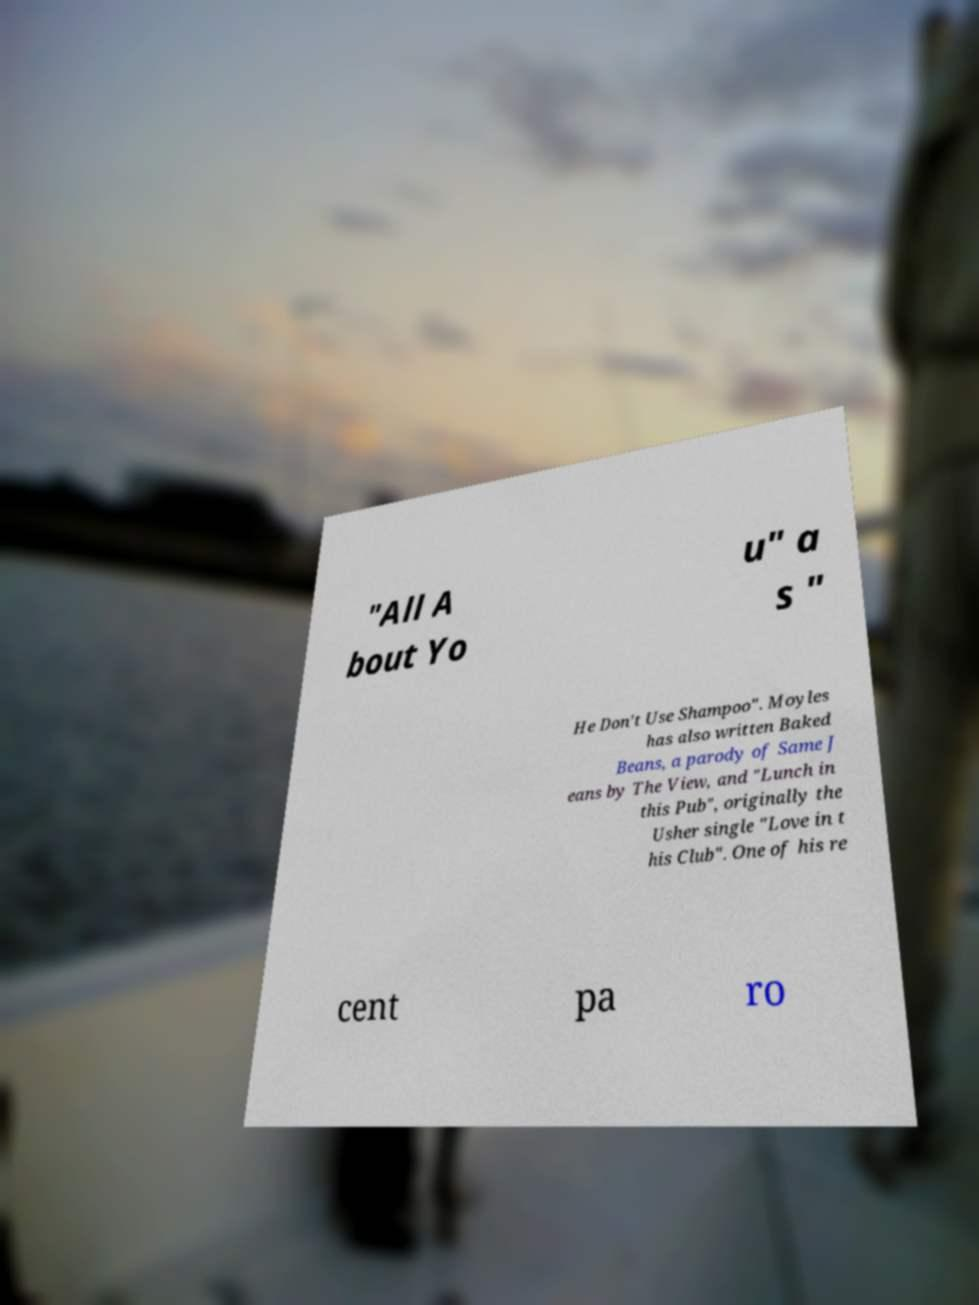For documentation purposes, I need the text within this image transcribed. Could you provide that? "All A bout Yo u" a s " He Don't Use Shampoo". Moyles has also written Baked Beans, a parody of Same J eans by The View, and "Lunch in this Pub", originally the Usher single "Love in t his Club". One of his re cent pa ro 